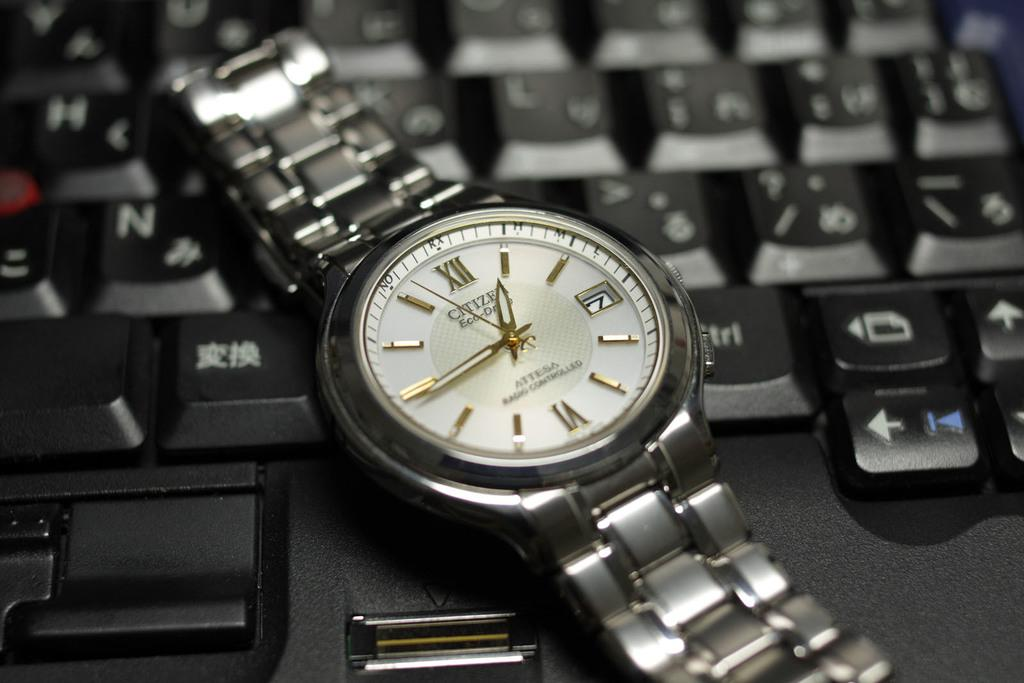<image>
Offer a succinct explanation of the picture presented. A metal band Citizen Eco Drive watch on a laptop keyboard. 